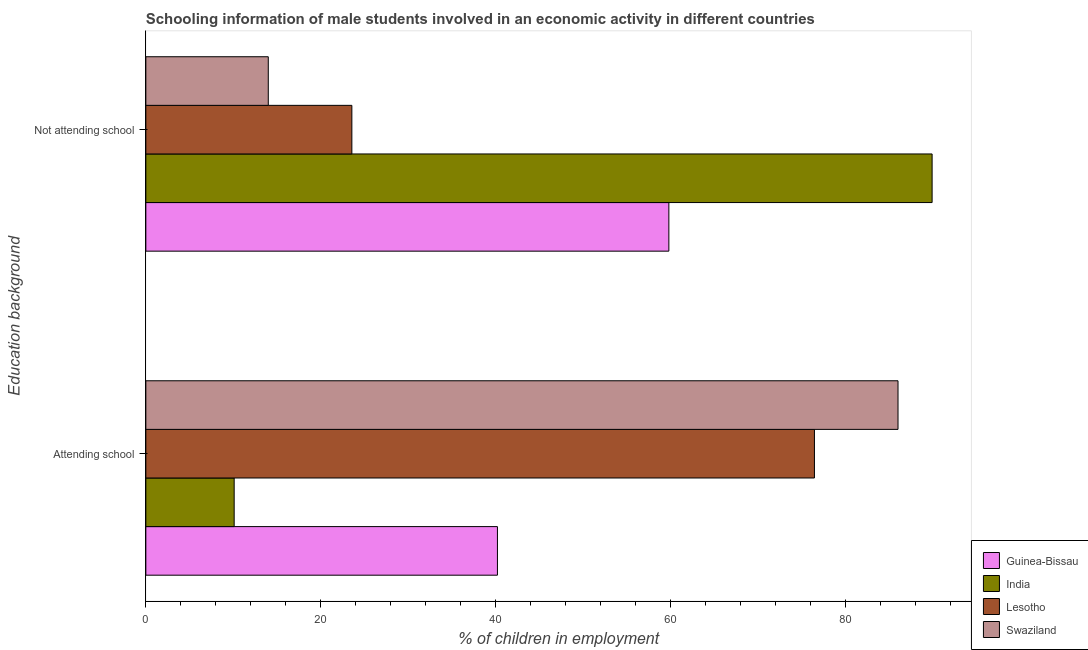Are the number of bars on each tick of the Y-axis equal?
Offer a terse response. Yes. How many bars are there on the 1st tick from the bottom?
Make the answer very short. 4. What is the label of the 2nd group of bars from the top?
Provide a succinct answer. Attending school. What is the percentage of employed males who are not attending school in Guinea-Bissau?
Make the answer very short. 59.8. Across all countries, what is the maximum percentage of employed males who are not attending school?
Provide a succinct answer. 89.9. In which country was the percentage of employed males who are attending school maximum?
Your answer should be compact. Swaziland. What is the total percentage of employed males who are attending school in the graph?
Keep it short and to the point. 212.75. What is the difference between the percentage of employed males who are not attending school in Swaziland and that in India?
Provide a short and direct response. -75.9. What is the difference between the percentage of employed males who are attending school in India and the percentage of employed males who are not attending school in Lesotho?
Your answer should be very brief. -13.45. What is the average percentage of employed males who are not attending school per country?
Offer a very short reply. 46.81. What is the difference between the percentage of employed males who are attending school and percentage of employed males who are not attending school in Guinea-Bissau?
Your answer should be compact. -19.6. In how many countries, is the percentage of employed males who are not attending school greater than 8 %?
Provide a short and direct response. 4. What is the ratio of the percentage of employed males who are not attending school in India to that in Guinea-Bissau?
Offer a very short reply. 1.5. In how many countries, is the percentage of employed males who are attending school greater than the average percentage of employed males who are attending school taken over all countries?
Ensure brevity in your answer.  2. What does the 4th bar from the top in Attending school represents?
Offer a very short reply. Guinea-Bissau. What does the 1st bar from the bottom in Not attending school represents?
Provide a short and direct response. Guinea-Bissau. How many countries are there in the graph?
Offer a very short reply. 4. Are the values on the major ticks of X-axis written in scientific E-notation?
Ensure brevity in your answer.  No. What is the title of the graph?
Give a very brief answer. Schooling information of male students involved in an economic activity in different countries. Does "El Salvador" appear as one of the legend labels in the graph?
Keep it short and to the point. No. What is the label or title of the X-axis?
Keep it short and to the point. % of children in employment. What is the label or title of the Y-axis?
Ensure brevity in your answer.  Education background. What is the % of children in employment in Guinea-Bissau in Attending school?
Ensure brevity in your answer.  40.2. What is the % of children in employment of India in Attending school?
Offer a very short reply. 10.1. What is the % of children in employment of Lesotho in Attending school?
Your response must be concise. 76.45. What is the % of children in employment in Swaziland in Attending school?
Provide a succinct answer. 86. What is the % of children in employment of Guinea-Bissau in Not attending school?
Provide a short and direct response. 59.8. What is the % of children in employment of India in Not attending school?
Provide a short and direct response. 89.9. What is the % of children in employment of Lesotho in Not attending school?
Offer a very short reply. 23.55. Across all Education background, what is the maximum % of children in employment of Guinea-Bissau?
Your answer should be compact. 59.8. Across all Education background, what is the maximum % of children in employment of India?
Give a very brief answer. 89.9. Across all Education background, what is the maximum % of children in employment in Lesotho?
Provide a succinct answer. 76.45. Across all Education background, what is the maximum % of children in employment of Swaziland?
Your response must be concise. 86. Across all Education background, what is the minimum % of children in employment in Guinea-Bissau?
Give a very brief answer. 40.2. Across all Education background, what is the minimum % of children in employment of Lesotho?
Give a very brief answer. 23.55. What is the total % of children in employment in India in the graph?
Offer a terse response. 100. What is the total % of children in employment in Lesotho in the graph?
Offer a very short reply. 100. What is the total % of children in employment of Swaziland in the graph?
Keep it short and to the point. 100. What is the difference between the % of children in employment in Guinea-Bissau in Attending school and that in Not attending school?
Make the answer very short. -19.6. What is the difference between the % of children in employment in India in Attending school and that in Not attending school?
Ensure brevity in your answer.  -79.8. What is the difference between the % of children in employment in Lesotho in Attending school and that in Not attending school?
Your response must be concise. 52.89. What is the difference between the % of children in employment in Swaziland in Attending school and that in Not attending school?
Make the answer very short. 72. What is the difference between the % of children in employment of Guinea-Bissau in Attending school and the % of children in employment of India in Not attending school?
Offer a terse response. -49.7. What is the difference between the % of children in employment of Guinea-Bissau in Attending school and the % of children in employment of Lesotho in Not attending school?
Your answer should be compact. 16.65. What is the difference between the % of children in employment in Guinea-Bissau in Attending school and the % of children in employment in Swaziland in Not attending school?
Your answer should be very brief. 26.2. What is the difference between the % of children in employment in India in Attending school and the % of children in employment in Lesotho in Not attending school?
Ensure brevity in your answer.  -13.45. What is the difference between the % of children in employment in Lesotho in Attending school and the % of children in employment in Swaziland in Not attending school?
Provide a short and direct response. 62.45. What is the average % of children in employment in Guinea-Bissau per Education background?
Provide a succinct answer. 50. What is the average % of children in employment in Lesotho per Education background?
Your answer should be compact. 50. What is the average % of children in employment of Swaziland per Education background?
Your answer should be compact. 50. What is the difference between the % of children in employment of Guinea-Bissau and % of children in employment of India in Attending school?
Offer a very short reply. 30.1. What is the difference between the % of children in employment of Guinea-Bissau and % of children in employment of Lesotho in Attending school?
Provide a succinct answer. -36.25. What is the difference between the % of children in employment of Guinea-Bissau and % of children in employment of Swaziland in Attending school?
Keep it short and to the point. -45.8. What is the difference between the % of children in employment of India and % of children in employment of Lesotho in Attending school?
Provide a short and direct response. -66.35. What is the difference between the % of children in employment of India and % of children in employment of Swaziland in Attending school?
Your answer should be very brief. -75.9. What is the difference between the % of children in employment of Lesotho and % of children in employment of Swaziland in Attending school?
Provide a succinct answer. -9.56. What is the difference between the % of children in employment of Guinea-Bissau and % of children in employment of India in Not attending school?
Make the answer very short. -30.1. What is the difference between the % of children in employment of Guinea-Bissau and % of children in employment of Lesotho in Not attending school?
Your answer should be very brief. 36.25. What is the difference between the % of children in employment in Guinea-Bissau and % of children in employment in Swaziland in Not attending school?
Make the answer very short. 45.8. What is the difference between the % of children in employment of India and % of children in employment of Lesotho in Not attending school?
Ensure brevity in your answer.  66.35. What is the difference between the % of children in employment of India and % of children in employment of Swaziland in Not attending school?
Provide a short and direct response. 75.9. What is the difference between the % of children in employment in Lesotho and % of children in employment in Swaziland in Not attending school?
Give a very brief answer. 9.55. What is the ratio of the % of children in employment of Guinea-Bissau in Attending school to that in Not attending school?
Ensure brevity in your answer.  0.67. What is the ratio of the % of children in employment in India in Attending school to that in Not attending school?
Your answer should be compact. 0.11. What is the ratio of the % of children in employment of Lesotho in Attending school to that in Not attending school?
Offer a very short reply. 3.25. What is the ratio of the % of children in employment of Swaziland in Attending school to that in Not attending school?
Provide a short and direct response. 6.14. What is the difference between the highest and the second highest % of children in employment in Guinea-Bissau?
Ensure brevity in your answer.  19.6. What is the difference between the highest and the second highest % of children in employment in India?
Make the answer very short. 79.8. What is the difference between the highest and the second highest % of children in employment of Lesotho?
Provide a short and direct response. 52.89. What is the difference between the highest and the second highest % of children in employment of Swaziland?
Offer a terse response. 72. What is the difference between the highest and the lowest % of children in employment of Guinea-Bissau?
Your answer should be very brief. 19.6. What is the difference between the highest and the lowest % of children in employment of India?
Your response must be concise. 79.8. What is the difference between the highest and the lowest % of children in employment of Lesotho?
Make the answer very short. 52.89. What is the difference between the highest and the lowest % of children in employment of Swaziland?
Keep it short and to the point. 72. 